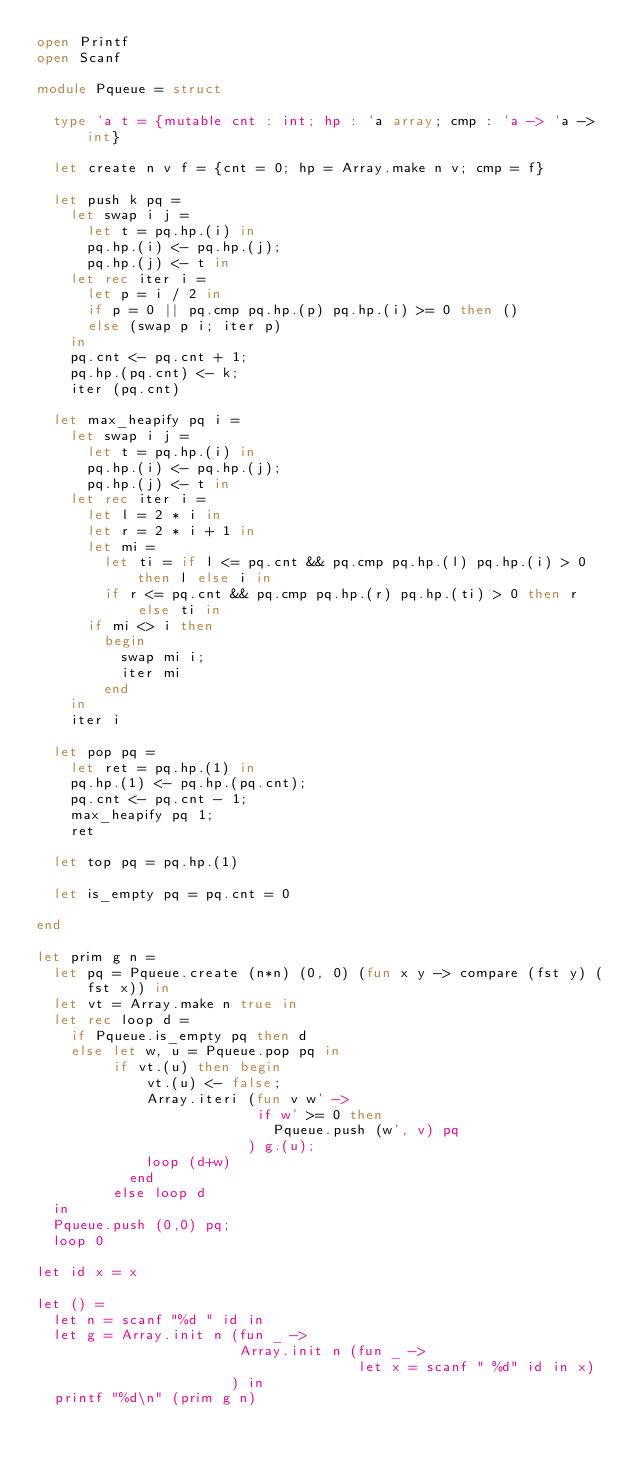<code> <loc_0><loc_0><loc_500><loc_500><_OCaml_>open Printf
open Scanf

module Pqueue = struct

  type 'a t = {mutable cnt : int; hp : 'a array; cmp : 'a -> 'a -> int}
                
  let create n v f = {cnt = 0; hp = Array.make n v; cmp = f}

  let push k pq =
    let swap i j =
      let t = pq.hp.(i) in
      pq.hp.(i) <- pq.hp.(j);
      pq.hp.(j) <- t in
    let rec iter i =
      let p = i / 2 in
      if p = 0 || pq.cmp pq.hp.(p) pq.hp.(i) >= 0 then ()
      else (swap p i; iter p)
    in
    pq.cnt <- pq.cnt + 1;
    pq.hp.(pq.cnt) <- k;
    iter (pq.cnt)

  let max_heapify pq i =
    let swap i j =
      let t = pq.hp.(i) in
      pq.hp.(i) <- pq.hp.(j);
      pq.hp.(j) <- t in
    let rec iter i =
      let l = 2 * i in
      let r = 2 * i + 1 in
      let mi =
        let ti = if l <= pq.cnt && pq.cmp pq.hp.(l) pq.hp.(i) > 0 then l else i in
        if r <= pq.cnt && pq.cmp pq.hp.(r) pq.hp.(ti) > 0 then r else ti in
      if mi <> i then
        begin
          swap mi i;
          iter mi
        end
    in
    iter i
  
  let pop pq =
    let ret = pq.hp.(1) in
    pq.hp.(1) <- pq.hp.(pq.cnt);
    pq.cnt <- pq.cnt - 1;
    max_heapify pq 1;
    ret

  let top pq = pq.hp.(1)
                    
  let is_empty pq = pq.cnt = 0
                               
end

let prim g n =
  let pq = Pqueue.create (n*n) (0, 0) (fun x y -> compare (fst y) (fst x)) in
  let vt = Array.make n true in
  let rec loop d =
    if Pqueue.is_empty pq then d
    else let w, u = Pqueue.pop pq in
         if vt.(u) then begin
             vt.(u) <- false;
             Array.iteri (fun v w' ->
                          if w' >= 0 then
                            Pqueue.push (w', v) pq
                         ) g.(u);
             loop (d+w)
           end
         else loop d
  in
  Pqueue.push (0,0) pq;
  loop 0

let id x = x
             
let () =
  let n = scanf "%d " id in
  let g = Array.init n (fun _ ->
                        Array.init n (fun _ ->
                                      let x = scanf " %d" id in x)
                       ) in
  printf "%d\n" (prim g n)</code> 